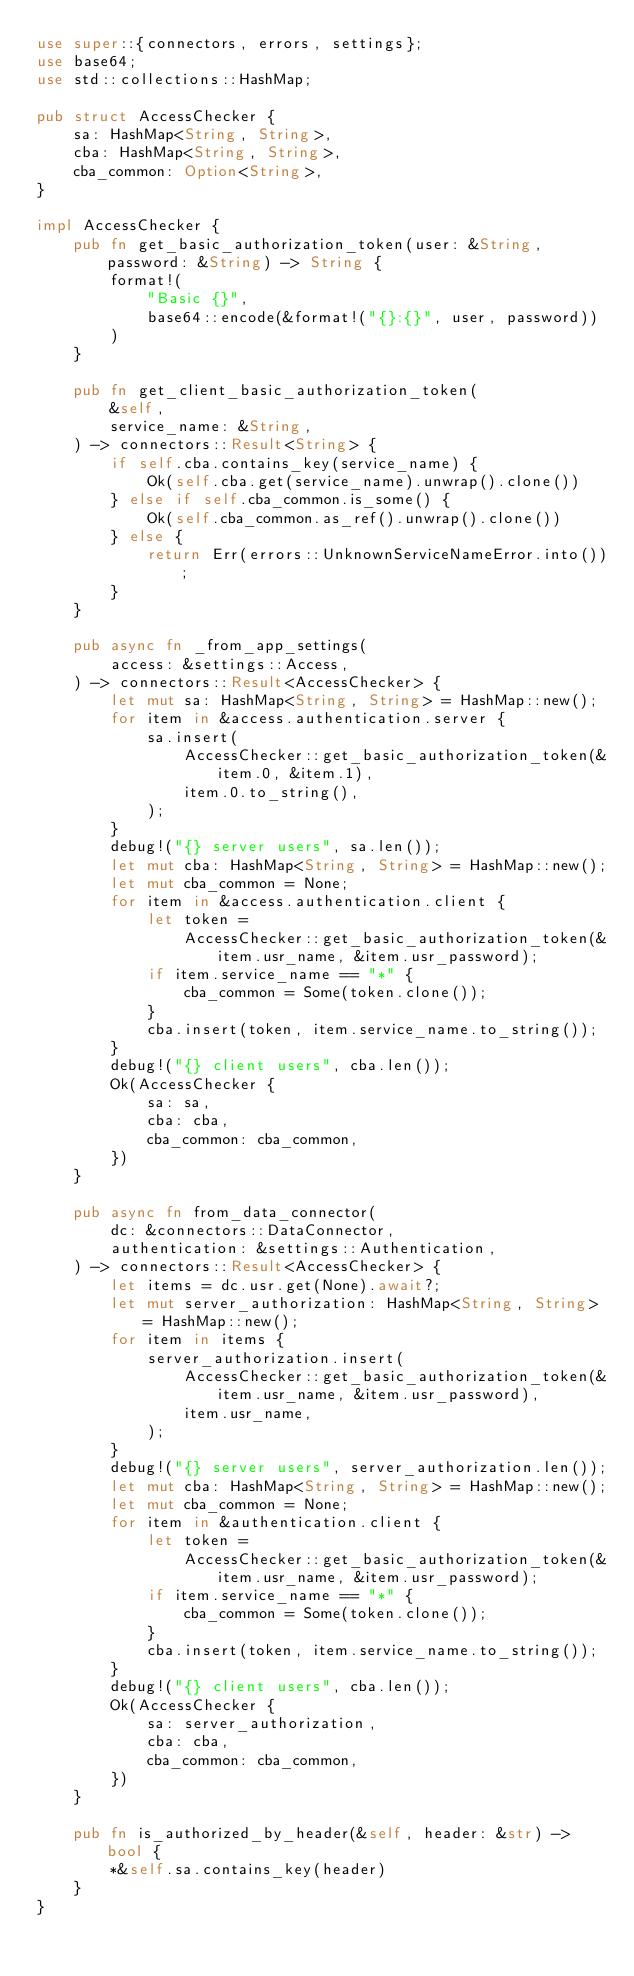<code> <loc_0><loc_0><loc_500><loc_500><_Rust_>use super::{connectors, errors, settings};
use base64;
use std::collections::HashMap;

pub struct AccessChecker {
    sa: HashMap<String, String>,
    cba: HashMap<String, String>,
    cba_common: Option<String>,
}

impl AccessChecker {
    pub fn get_basic_authorization_token(user: &String, password: &String) -> String {
        format!(
            "Basic {}",
            base64::encode(&format!("{}:{}", user, password))
        )
    }

    pub fn get_client_basic_authorization_token(
        &self,
        service_name: &String,
    ) -> connectors::Result<String> {
        if self.cba.contains_key(service_name) {
            Ok(self.cba.get(service_name).unwrap().clone())
        } else if self.cba_common.is_some() {
            Ok(self.cba_common.as_ref().unwrap().clone())
        } else {
            return Err(errors::UnknownServiceNameError.into());
        }
    }

    pub async fn _from_app_settings(
        access: &settings::Access,
    ) -> connectors::Result<AccessChecker> {
        let mut sa: HashMap<String, String> = HashMap::new();
        for item in &access.authentication.server {
            sa.insert(
                AccessChecker::get_basic_authorization_token(&item.0, &item.1),
                item.0.to_string(),
            );
        }
        debug!("{} server users", sa.len());
        let mut cba: HashMap<String, String> = HashMap::new();
        let mut cba_common = None;
        for item in &access.authentication.client {
            let token =
                AccessChecker::get_basic_authorization_token(&item.usr_name, &item.usr_password);
            if item.service_name == "*" {
                cba_common = Some(token.clone());
            }
            cba.insert(token, item.service_name.to_string());
        }
        debug!("{} client users", cba.len());
        Ok(AccessChecker {
            sa: sa,
            cba: cba,
            cba_common: cba_common,
        })
    }

    pub async fn from_data_connector(
        dc: &connectors::DataConnector,
        authentication: &settings::Authentication,
    ) -> connectors::Result<AccessChecker> {
        let items = dc.usr.get(None).await?;
        let mut server_authorization: HashMap<String, String> = HashMap::new();
        for item in items {
            server_authorization.insert(
                AccessChecker::get_basic_authorization_token(&item.usr_name, &item.usr_password),
                item.usr_name,
            );
        }
        debug!("{} server users", server_authorization.len());
        let mut cba: HashMap<String, String> = HashMap::new();
        let mut cba_common = None;
        for item in &authentication.client {
            let token =
                AccessChecker::get_basic_authorization_token(&item.usr_name, &item.usr_password);
            if item.service_name == "*" {
                cba_common = Some(token.clone());
            }
            cba.insert(token, item.service_name.to_string());
        }
        debug!("{} client users", cba.len());
        Ok(AccessChecker {
            sa: server_authorization,
            cba: cba,
            cba_common: cba_common,
        })
    }

    pub fn is_authorized_by_header(&self, header: &str) -> bool {
        *&self.sa.contains_key(header)
    }
}
</code> 